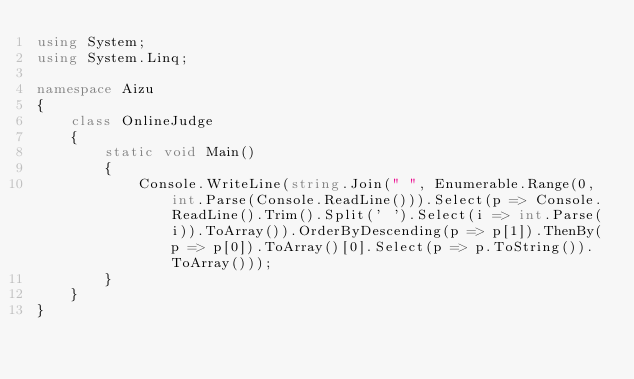Convert code to text. <code><loc_0><loc_0><loc_500><loc_500><_C#_>using System;
using System.Linq;

namespace Aizu
{
    class OnlineJudge
    {
        static void Main()
        {
            Console.WriteLine(string.Join(" ", Enumerable.Range(0, int.Parse(Console.ReadLine())).Select(p => Console.ReadLine().Trim().Split(' ').Select(i => int.Parse(i)).ToArray()).OrderByDescending(p => p[1]).ThenBy(p => p[0]).ToArray()[0].Select(p => p.ToString()).ToArray()));
        }
    }
}</code> 